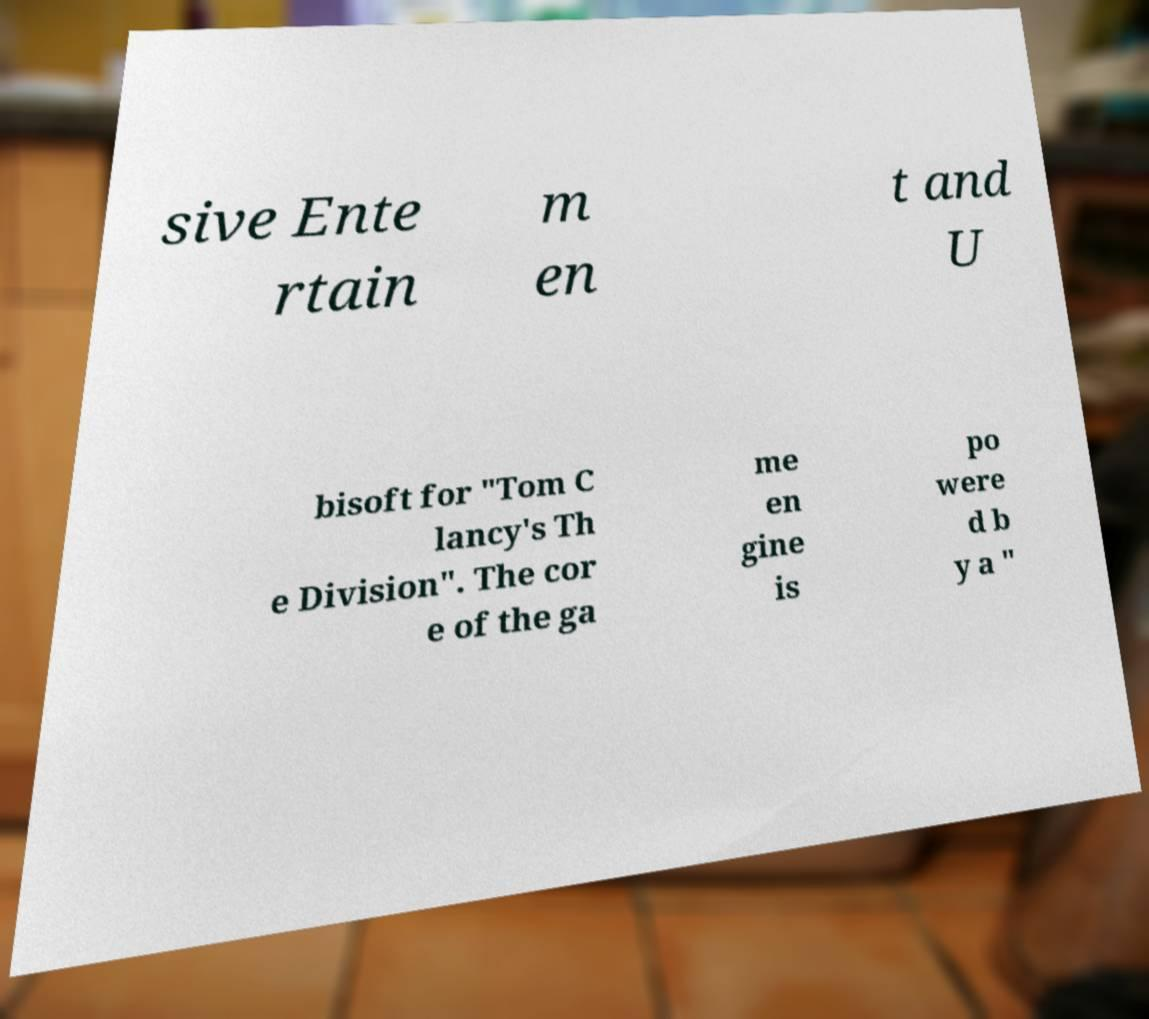Can you read and provide the text displayed in the image?This photo seems to have some interesting text. Can you extract and type it out for me? sive Ente rtain m en t and U bisoft for "Tom C lancy's Th e Division". The cor e of the ga me en gine is po were d b y a " 